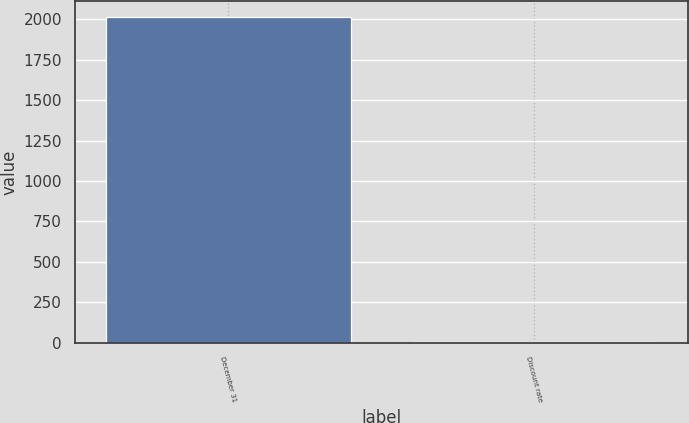<chart> <loc_0><loc_0><loc_500><loc_500><bar_chart><fcel>December 31<fcel>Discount rate<nl><fcel>2013<fcel>5.15<nl></chart> 